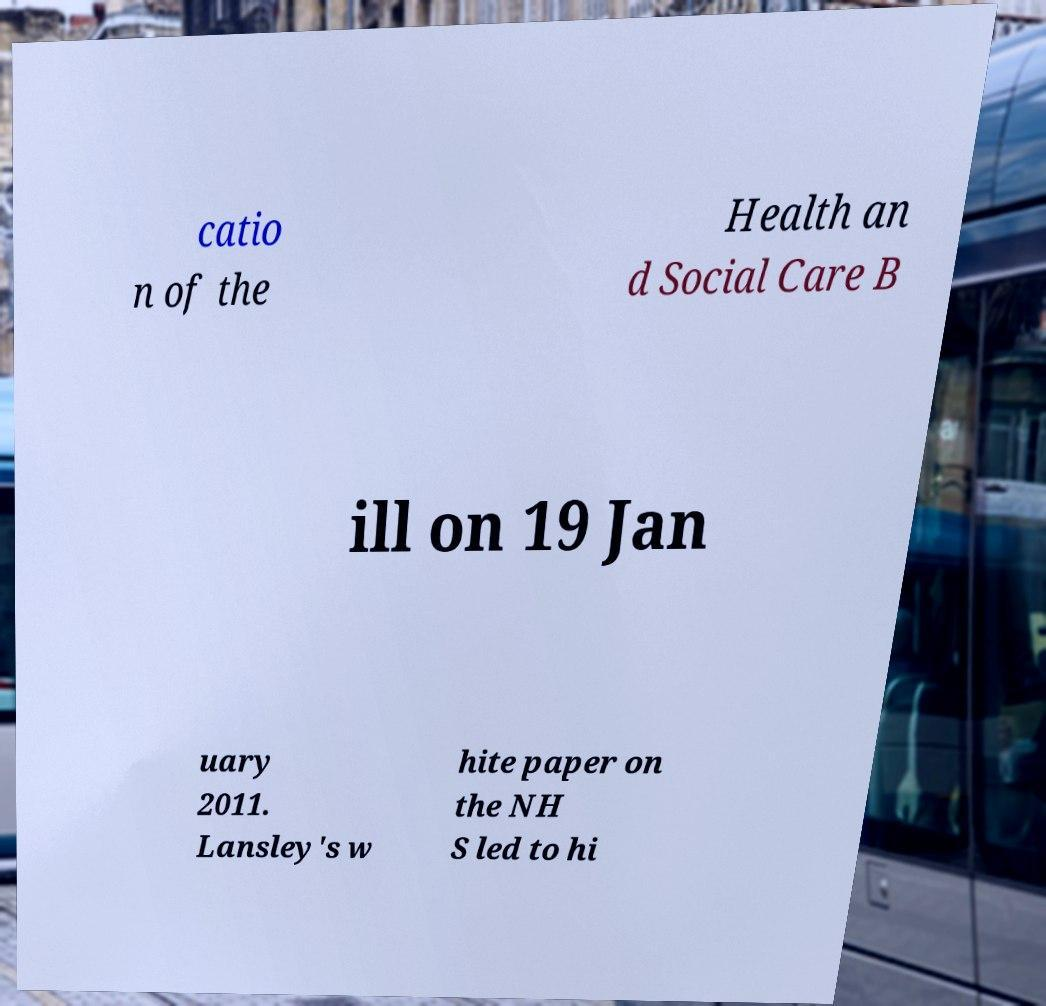Can you accurately transcribe the text from the provided image for me? catio n of the Health an d Social Care B ill on 19 Jan uary 2011. Lansley's w hite paper on the NH S led to hi 